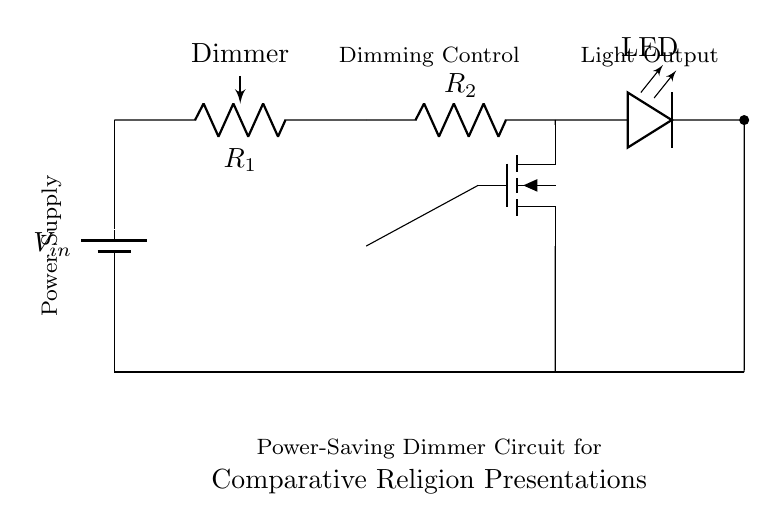What is the main component used for dimming in this circuit? The main component used for dimming is the potentiometer, labeled as "Dimmer." It allows for variable resistance to adjust the brightness of the LED.
Answer: Potentiometer What does the MOSFET control in the circuit? The MOSFET controls the current flowing to the LED, enabling it to turn on and off or adjust its brightness based on the potentiometer's setting.
Answer: LED brightness How many resistors are present in this circuit? There are two resistors in the circuit: the potentiometer (R1) for dimming and a fixed resistor (R2) for current limiting.
Answer: Two What is the function of the resistor labeled R2? Resistor R2 functions as a current-limiting resistor for the LED, preventing excess current that could damage the LED.
Answer: Current limiting What type of power source is used in this circuit? The power source used is a battery, which provides the necessary voltage to power the circuit components.
Answer: Battery How does adjusting the potentiometer affect the circuit? Adjusting the potentiometer changes its resistance, which in turn adjusts the voltage at the gate of the MOSFET, allowing for control over the LED’s brightness.
Answer: Changes brightness What is the connection between the MOSFET and the LED? The MOSFET is connected to the LED in a configuration that allows it to control the current flowing through the LED based on the gate voltage.
Answer: Controls LED current 